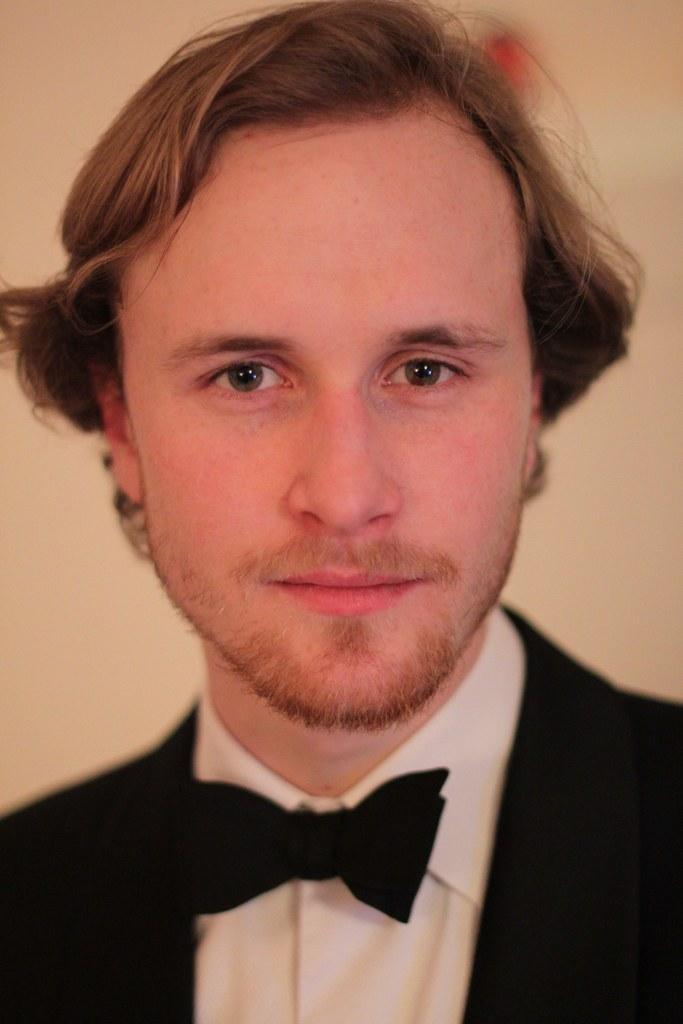Can you describe this image briefly? As we can see in the image in the front there is a man wearing black color jacket and there is wall. 